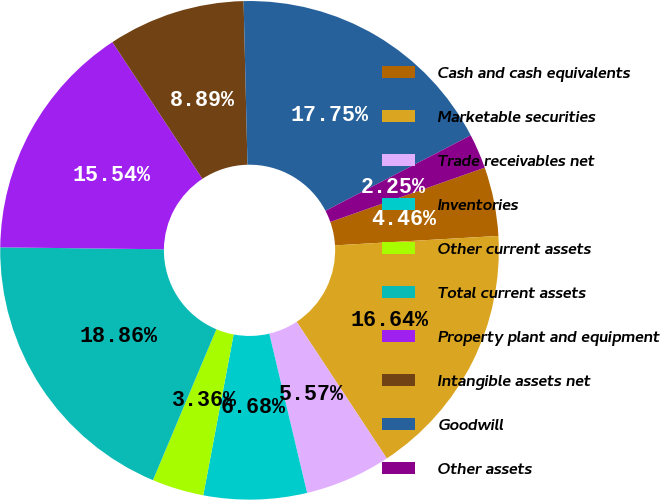<chart> <loc_0><loc_0><loc_500><loc_500><pie_chart><fcel>Cash and cash equivalents<fcel>Marketable securities<fcel>Trade receivables net<fcel>Inventories<fcel>Other current assets<fcel>Total current assets<fcel>Property plant and equipment<fcel>Intangible assets net<fcel>Goodwill<fcel>Other assets<nl><fcel>4.46%<fcel>16.64%<fcel>5.57%<fcel>6.68%<fcel>3.36%<fcel>18.86%<fcel>15.54%<fcel>8.89%<fcel>17.75%<fcel>2.25%<nl></chart> 